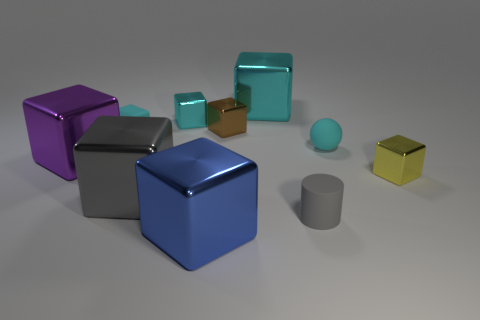Subtract all big purple shiny cubes. How many cubes are left? 7 Subtract all cyan balls. How many cyan blocks are left? 3 Subtract 2 blocks. How many blocks are left? 6 Subtract all cyan blocks. How many blocks are left? 5 Subtract all gray blocks. Subtract all gray balls. How many blocks are left? 7 Subtract all spheres. How many objects are left? 9 Subtract all blue blocks. Subtract all tiny cyan blocks. How many objects are left? 7 Add 5 cyan matte spheres. How many cyan matte spheres are left? 6 Add 1 tiny brown cubes. How many tiny brown cubes exist? 2 Subtract 0 brown cylinders. How many objects are left? 10 